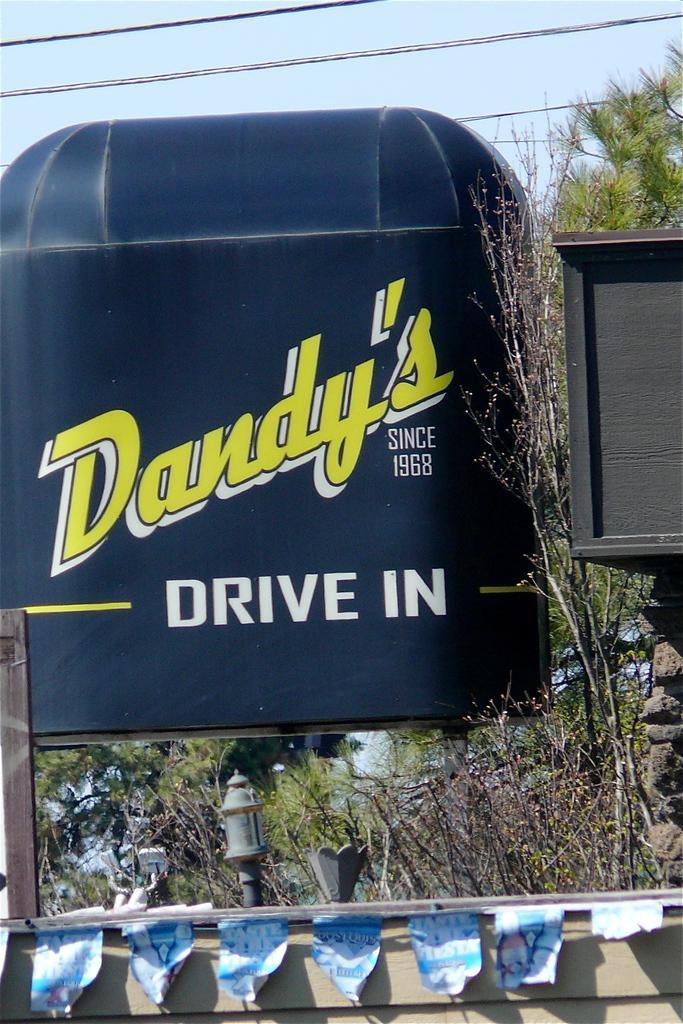Please provide a concise description of this image. In the picture I can see a black color object which has something written on it. I can also see plants, wires and some other things. In the background I can see the sky. 